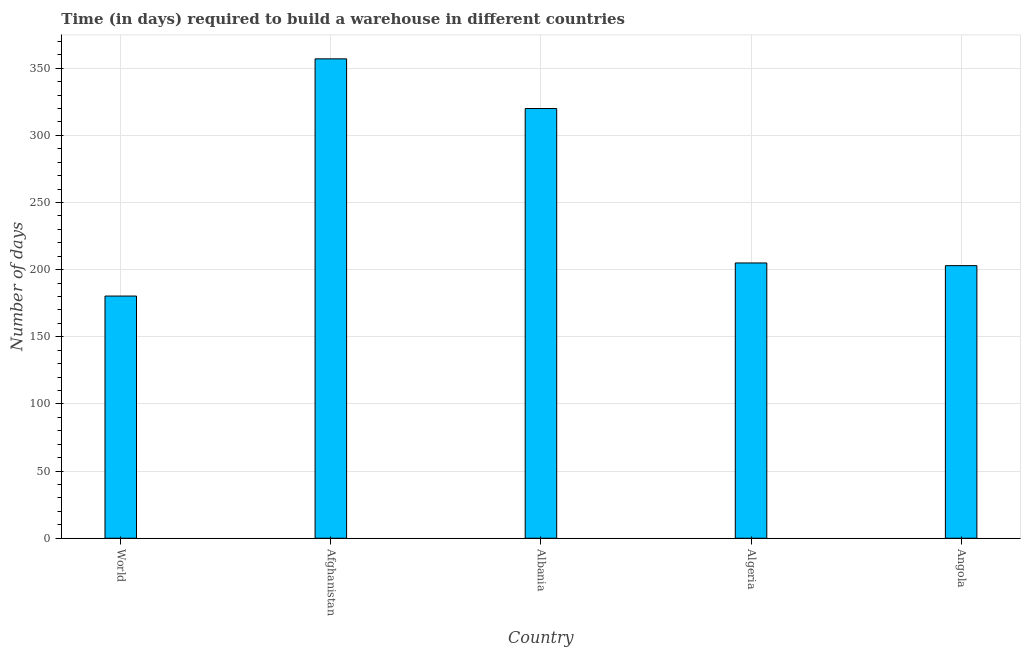Does the graph contain any zero values?
Provide a short and direct response. No. Does the graph contain grids?
Ensure brevity in your answer.  Yes. What is the title of the graph?
Offer a terse response. Time (in days) required to build a warehouse in different countries. What is the label or title of the Y-axis?
Provide a short and direct response. Number of days. What is the time required to build a warehouse in Algeria?
Your answer should be compact. 205. Across all countries, what is the maximum time required to build a warehouse?
Provide a succinct answer. 357. Across all countries, what is the minimum time required to build a warehouse?
Your answer should be compact. 180.35. In which country was the time required to build a warehouse maximum?
Your response must be concise. Afghanistan. What is the sum of the time required to build a warehouse?
Provide a succinct answer. 1265.35. What is the difference between the time required to build a warehouse in Afghanistan and Angola?
Give a very brief answer. 154. What is the average time required to build a warehouse per country?
Offer a very short reply. 253.07. What is the median time required to build a warehouse?
Ensure brevity in your answer.  205. In how many countries, is the time required to build a warehouse greater than 60 days?
Your response must be concise. 5. What is the ratio of the time required to build a warehouse in Albania to that in World?
Provide a succinct answer. 1.77. Is the time required to build a warehouse in Afghanistan less than that in Angola?
Your answer should be very brief. No. Is the difference between the time required to build a warehouse in Afghanistan and Algeria greater than the difference between any two countries?
Offer a terse response. No. What is the difference between the highest and the second highest time required to build a warehouse?
Ensure brevity in your answer.  37. Is the sum of the time required to build a warehouse in Albania and World greater than the maximum time required to build a warehouse across all countries?
Keep it short and to the point. Yes. What is the difference between the highest and the lowest time required to build a warehouse?
Offer a very short reply. 176.65. How many bars are there?
Provide a short and direct response. 5. How many countries are there in the graph?
Keep it short and to the point. 5. Are the values on the major ticks of Y-axis written in scientific E-notation?
Give a very brief answer. No. What is the Number of days of World?
Your response must be concise. 180.35. What is the Number of days of Afghanistan?
Keep it short and to the point. 357. What is the Number of days of Albania?
Provide a succinct answer. 320. What is the Number of days in Algeria?
Your response must be concise. 205. What is the Number of days of Angola?
Your answer should be compact. 203. What is the difference between the Number of days in World and Afghanistan?
Keep it short and to the point. -176.65. What is the difference between the Number of days in World and Albania?
Ensure brevity in your answer.  -139.65. What is the difference between the Number of days in World and Algeria?
Ensure brevity in your answer.  -24.65. What is the difference between the Number of days in World and Angola?
Offer a very short reply. -22.65. What is the difference between the Number of days in Afghanistan and Algeria?
Provide a succinct answer. 152. What is the difference between the Number of days in Afghanistan and Angola?
Make the answer very short. 154. What is the difference between the Number of days in Albania and Algeria?
Offer a terse response. 115. What is the difference between the Number of days in Albania and Angola?
Offer a very short reply. 117. What is the ratio of the Number of days in World to that in Afghanistan?
Your response must be concise. 0.51. What is the ratio of the Number of days in World to that in Albania?
Provide a short and direct response. 0.56. What is the ratio of the Number of days in World to that in Algeria?
Provide a succinct answer. 0.88. What is the ratio of the Number of days in World to that in Angola?
Offer a terse response. 0.89. What is the ratio of the Number of days in Afghanistan to that in Albania?
Ensure brevity in your answer.  1.12. What is the ratio of the Number of days in Afghanistan to that in Algeria?
Keep it short and to the point. 1.74. What is the ratio of the Number of days in Afghanistan to that in Angola?
Keep it short and to the point. 1.76. What is the ratio of the Number of days in Albania to that in Algeria?
Your response must be concise. 1.56. What is the ratio of the Number of days in Albania to that in Angola?
Offer a terse response. 1.58. What is the ratio of the Number of days in Algeria to that in Angola?
Your answer should be very brief. 1.01. 